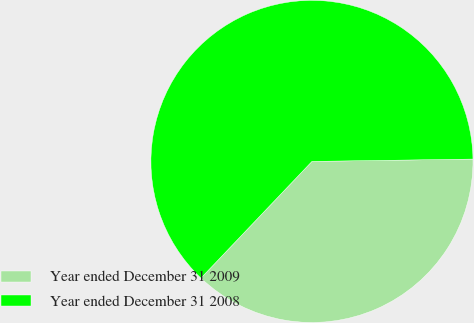<chart> <loc_0><loc_0><loc_500><loc_500><pie_chart><fcel>Year ended December 31 2009<fcel>Year ended December 31 2008<nl><fcel>37.34%<fcel>62.66%<nl></chart> 